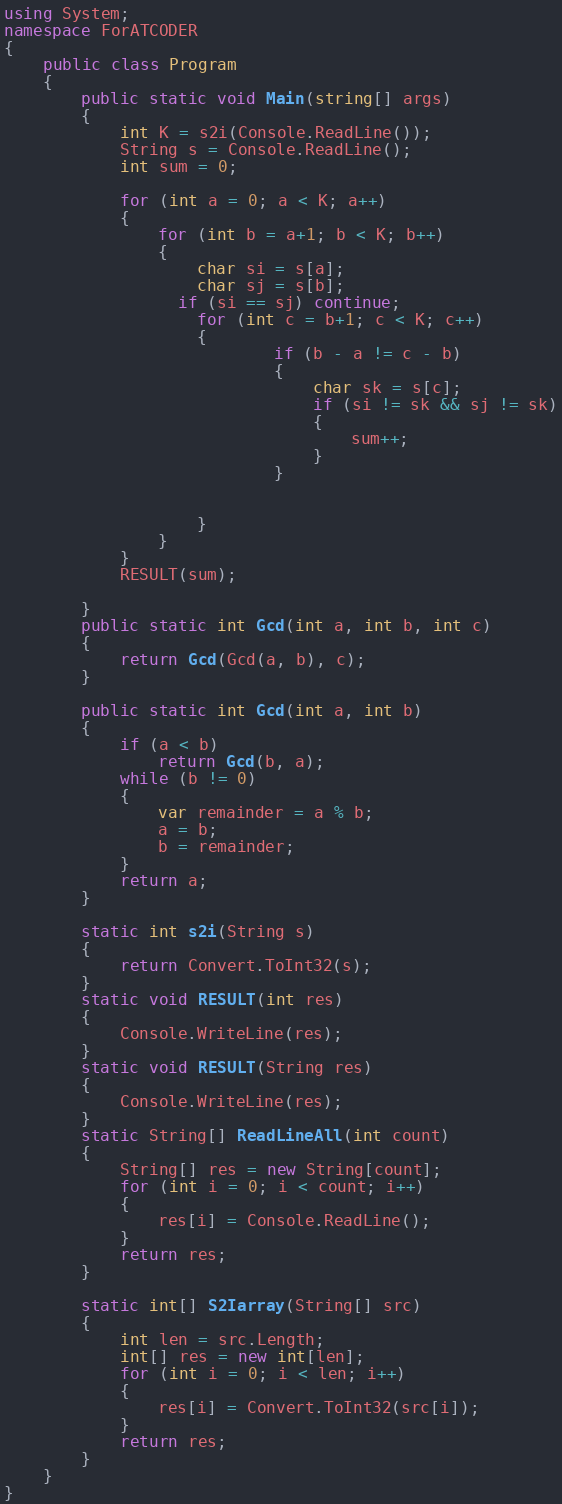<code> <loc_0><loc_0><loc_500><loc_500><_C#_>using System;
namespace ForATCODER
{
    public class Program
    {
        public static void Main(string[] args)
        {
            int K = s2i(Console.ReadLine());
            String s = Console.ReadLine();
            int sum = 0;

            for (int a = 0; a < K; a++)
            {
                for (int b = a+1; b < K; b++)
                {
                    char si = s[a];
                    char sj = s[b];
                  if (si == sj) continue;
                    for (int c = b+1; c < K; c++)
                    {
                            if (b - a != c - b)
                            {
                                char sk = s[c];
                                if (si != sk && sj != sk)
                                {
                                    sum++;
                                }
                            }
                        

                    }
                }
            }
            RESULT(sum);

        }
        public static int Gcd(int a, int b, int c)
        {
            return Gcd(Gcd(a, b), c);
        }

        public static int Gcd(int a, int b)
        {
            if (a < b)
                return Gcd(b, a);
            while (b != 0)
            {
                var remainder = a % b;
                a = b;
                b = remainder;
            }
            return a;
        }

        static int s2i(String s)
        {
            return Convert.ToInt32(s);
        }
        static void RESULT(int res)
        {
            Console.WriteLine(res);
        }
        static void RESULT(String res)
        {
            Console.WriteLine(res);
        }
        static String[] ReadLineAll(int count)
        {
            String[] res = new String[count];
            for (int i = 0; i < count; i++)
            {
                res[i] = Console.ReadLine();
            }
            return res;
        }

        static int[] S2Iarray(String[] src)
        {
            int len = src.Length;
            int[] res = new int[len];
            for (int i = 0; i < len; i++)
            {
                res[i] = Convert.ToInt32(src[i]);
            }
            return res;
        }
    }
}
</code> 